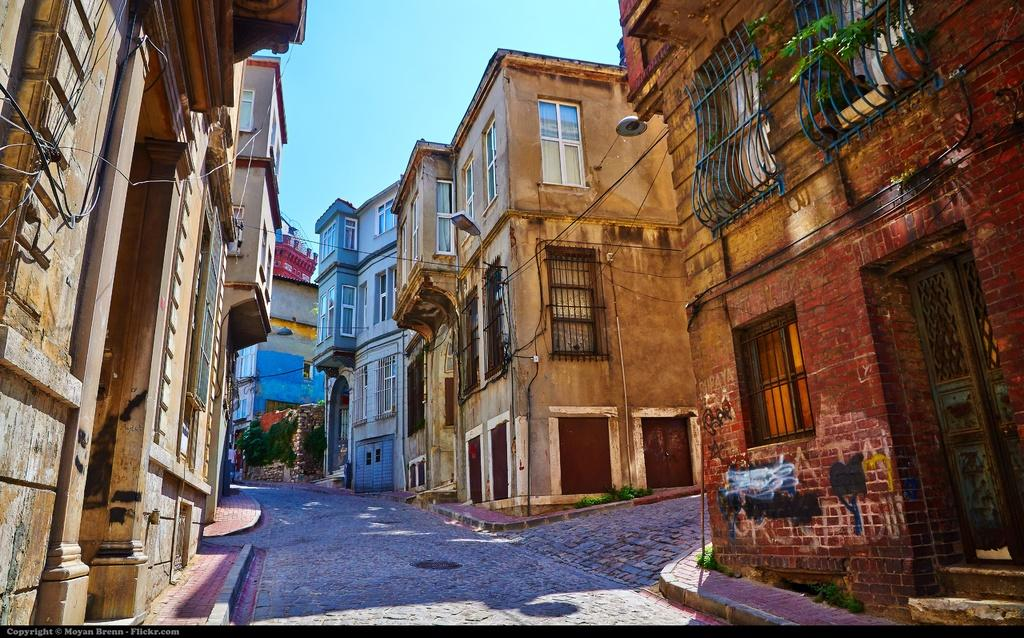What is the main feature in the center of the image? There is a road in the center of the image. What can be seen on the right side of the image? There are buildings on the right side of the image. What can be seen on the left side of the image? There are buildings on the left side of the image. What is visible in the background of the image? The sky is visible in the background of the image. What type of cord is being used by the carpenter in the image? There is no carpenter or cord present in the image. What trail can be seen leading into the forest in the image? There is no trail or forest present in the image. 